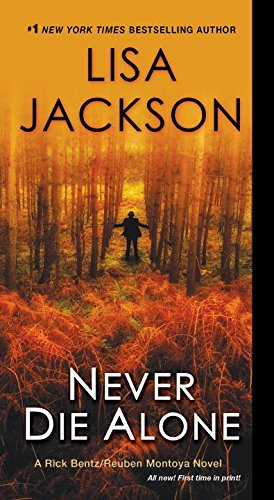Can you describe the mood or atmosphere suggested by the book cover? The book cover suggests a mysterious and slightly ominous mood, with a solitary figure walking through a dense, foggy forest. The autumn colors and dim lighting enhance the feeling of solitude and suspense, drawing readers into the eerie setting of the story. 